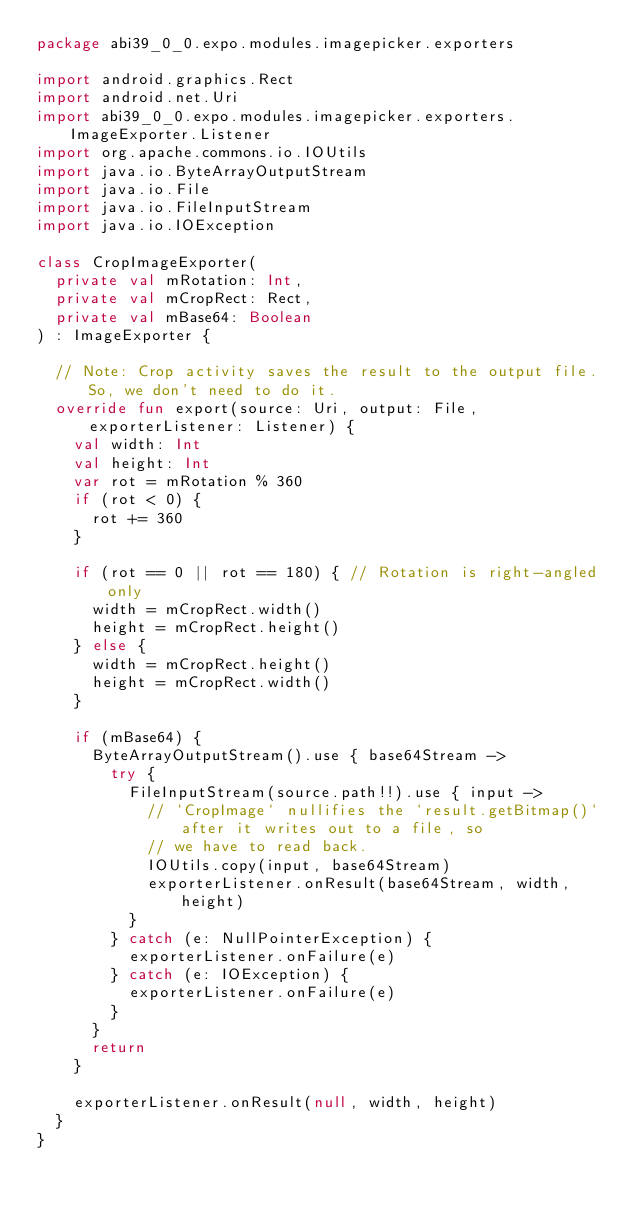Convert code to text. <code><loc_0><loc_0><loc_500><loc_500><_Kotlin_>package abi39_0_0.expo.modules.imagepicker.exporters

import android.graphics.Rect
import android.net.Uri
import abi39_0_0.expo.modules.imagepicker.exporters.ImageExporter.Listener
import org.apache.commons.io.IOUtils
import java.io.ByteArrayOutputStream
import java.io.File
import java.io.FileInputStream
import java.io.IOException

class CropImageExporter(
  private val mRotation: Int,
  private val mCropRect: Rect,
  private val mBase64: Boolean
) : ImageExporter {

  // Note: Crop activity saves the result to the output file. So, we don't need to do it.
  override fun export(source: Uri, output: File, exporterListener: Listener) {
    val width: Int
    val height: Int
    var rot = mRotation % 360
    if (rot < 0) {
      rot += 360
    }

    if (rot == 0 || rot == 180) { // Rotation is right-angled only
      width = mCropRect.width()
      height = mCropRect.height()
    } else {
      width = mCropRect.height()
      height = mCropRect.width()
    }

    if (mBase64) {
      ByteArrayOutputStream().use { base64Stream ->
        try {
          FileInputStream(source.path!!).use { input ->
            // `CropImage` nullifies the `result.getBitmap()` after it writes out to a file, so
            // we have to read back.
            IOUtils.copy(input, base64Stream)
            exporterListener.onResult(base64Stream, width, height)
          }
        } catch (e: NullPointerException) {
          exporterListener.onFailure(e)
        } catch (e: IOException) {
          exporterListener.onFailure(e)
        }
      }
      return
    }

    exporterListener.onResult(null, width, height)
  }
}
</code> 